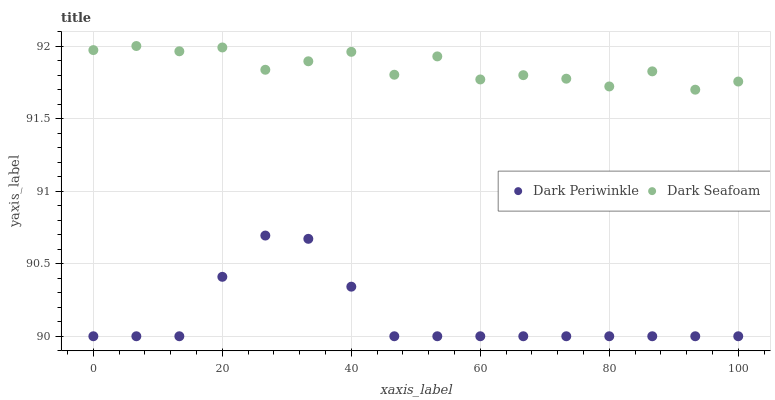Does Dark Periwinkle have the minimum area under the curve?
Answer yes or no. Yes. Does Dark Seafoam have the maximum area under the curve?
Answer yes or no. Yes. Does Dark Periwinkle have the maximum area under the curve?
Answer yes or no. No. Is Dark Periwinkle the smoothest?
Answer yes or no. Yes. Is Dark Seafoam the roughest?
Answer yes or no. Yes. Is Dark Periwinkle the roughest?
Answer yes or no. No. Does Dark Periwinkle have the lowest value?
Answer yes or no. Yes. Does Dark Seafoam have the highest value?
Answer yes or no. Yes. Does Dark Periwinkle have the highest value?
Answer yes or no. No. Is Dark Periwinkle less than Dark Seafoam?
Answer yes or no. Yes. Is Dark Seafoam greater than Dark Periwinkle?
Answer yes or no. Yes. Does Dark Periwinkle intersect Dark Seafoam?
Answer yes or no. No. 